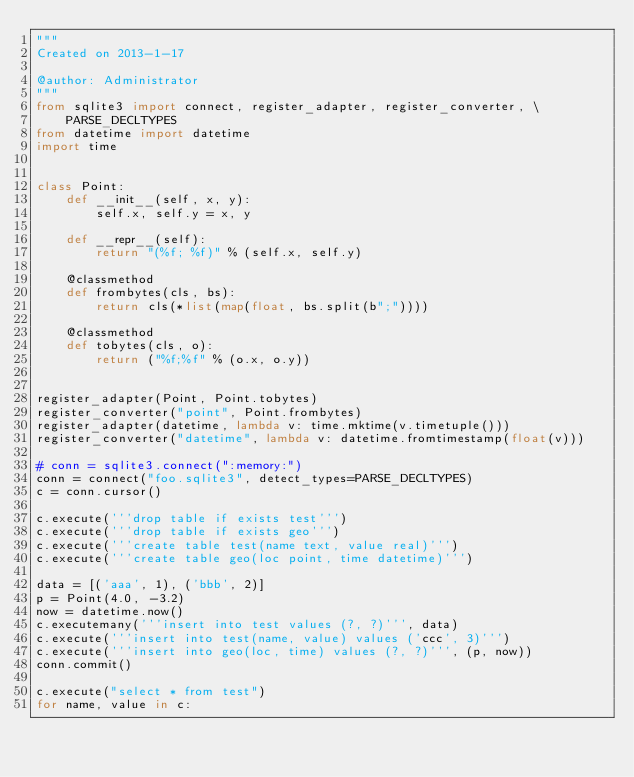<code> <loc_0><loc_0><loc_500><loc_500><_Python_>"""
Created on 2013-1-17

@author: Administrator
"""
from sqlite3 import connect, register_adapter, register_converter, \
    PARSE_DECLTYPES
from datetime import datetime
import time


class Point:
    def __init__(self, x, y):
        self.x, self.y = x, y

    def __repr__(self):
        return "(%f; %f)" % (self.x, self.y)

    @classmethod
    def frombytes(cls, bs):
        return cls(*list(map(float, bs.split(b";"))))

    @classmethod
    def tobytes(cls, o):
        return ("%f;%f" % (o.x, o.y))


register_adapter(Point, Point.tobytes)
register_converter("point", Point.frombytes)
register_adapter(datetime, lambda v: time.mktime(v.timetuple()))
register_converter("datetime", lambda v: datetime.fromtimestamp(float(v)))

# conn = sqlite3.connect(":memory:")
conn = connect("foo.sqlite3", detect_types=PARSE_DECLTYPES)
c = conn.cursor()

c.execute('''drop table if exists test''')
c.execute('''drop table if exists geo''')
c.execute('''create table test(name text, value real)''')
c.execute('''create table geo(loc point, time datetime)''')

data = [('aaa', 1), ('bbb', 2)]
p = Point(4.0, -3.2)
now = datetime.now()
c.executemany('''insert into test values (?, ?)''', data)
c.execute('''insert into test(name, value) values ('ccc', 3)''')
c.execute('''insert into geo(loc, time) values (?, ?)''', (p, now))
conn.commit()

c.execute("select * from test")
for name, value in c:</code> 